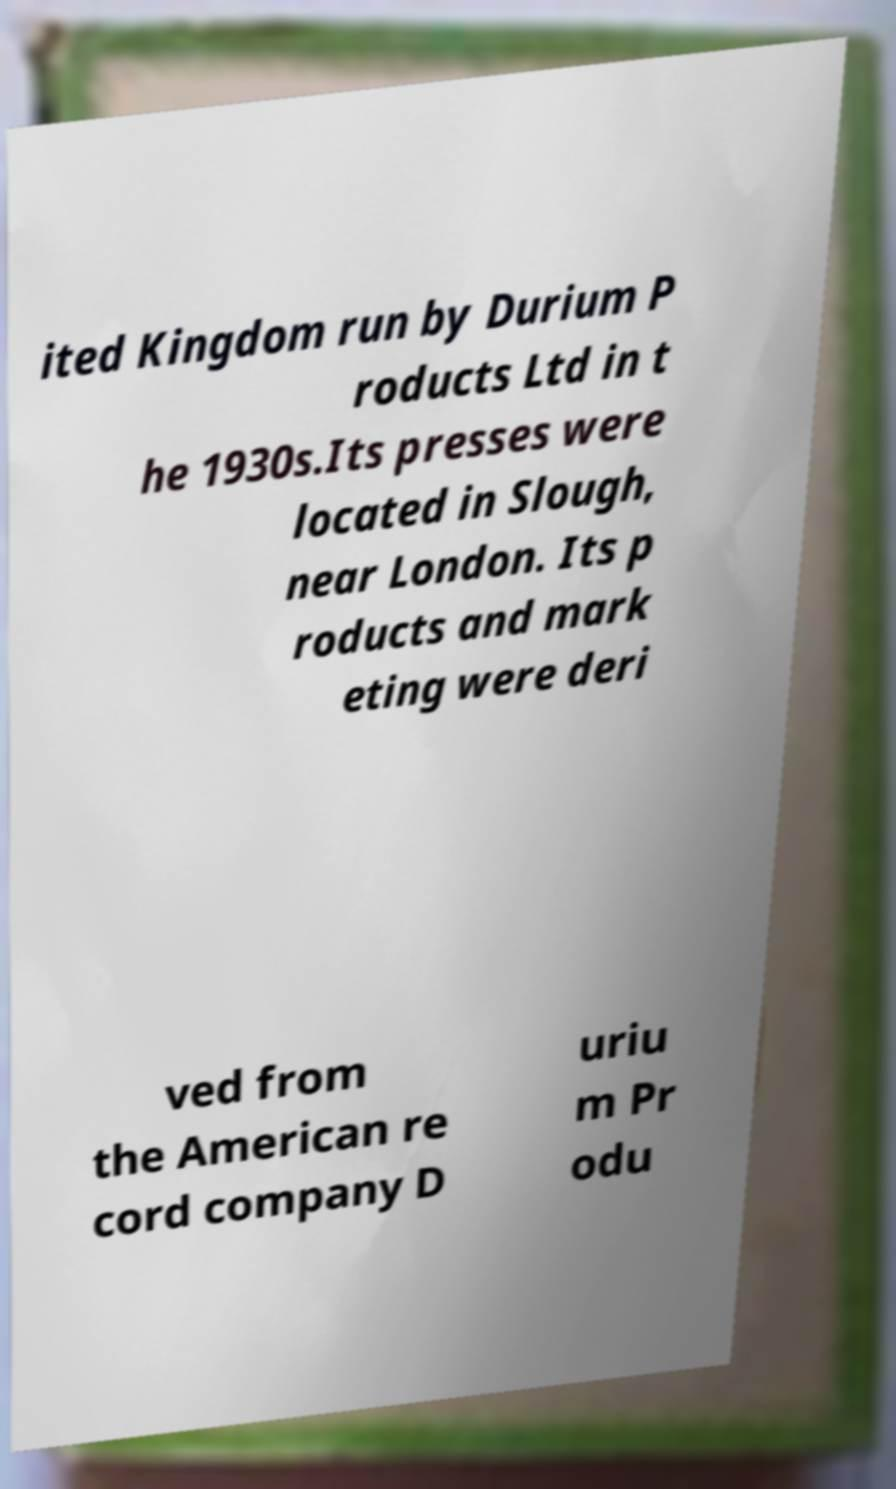There's text embedded in this image that I need extracted. Can you transcribe it verbatim? ited Kingdom run by Durium P roducts Ltd in t he 1930s.Its presses were located in Slough, near London. Its p roducts and mark eting were deri ved from the American re cord company D uriu m Pr odu 